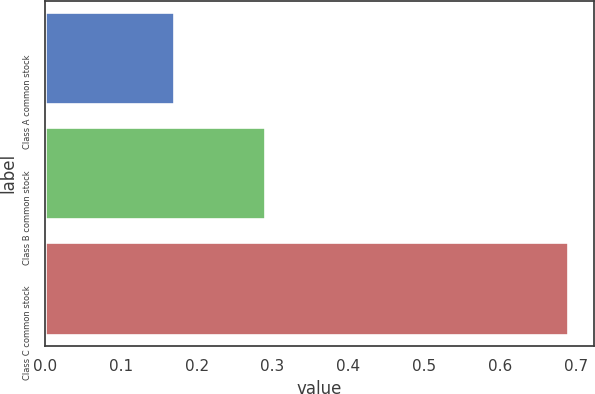<chart> <loc_0><loc_0><loc_500><loc_500><bar_chart><fcel>Class A common stock<fcel>Class B common stock<fcel>Class C common stock<nl><fcel>0.17<fcel>0.29<fcel>0.69<nl></chart> 